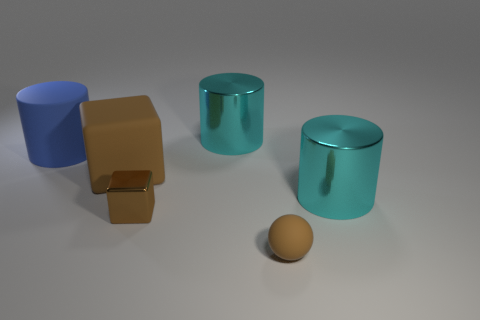Add 2 tiny blue spheres. How many objects exist? 8 Subtract all spheres. How many objects are left? 5 Add 5 tiny brown rubber objects. How many tiny brown rubber objects are left? 6 Add 3 cyan cylinders. How many cyan cylinders exist? 5 Subtract 0 cyan cubes. How many objects are left? 6 Subtract all brown metal blocks. Subtract all small blue shiny balls. How many objects are left? 5 